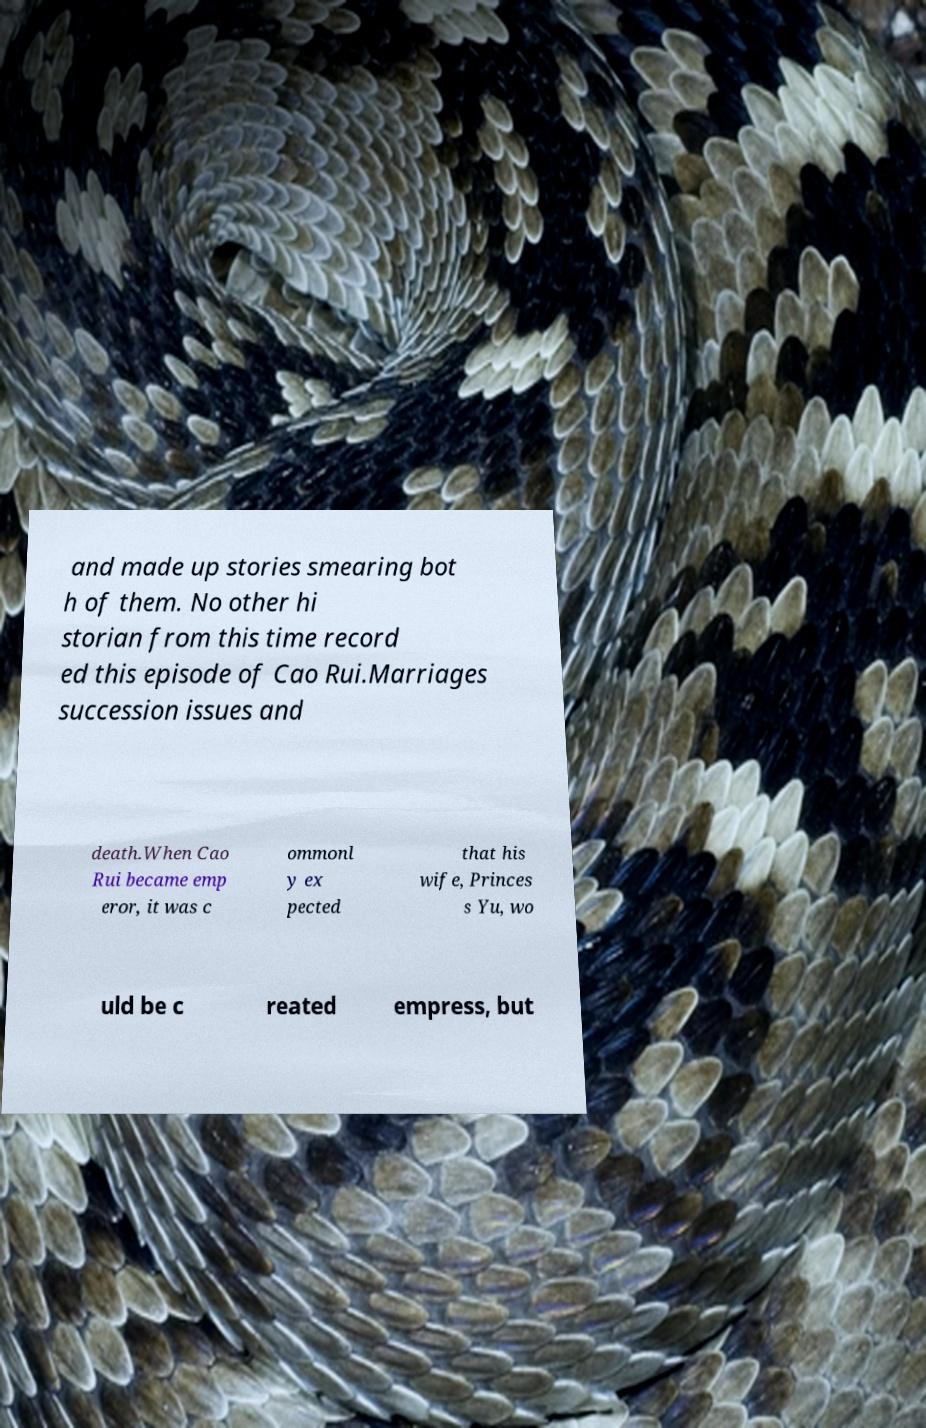Can you accurately transcribe the text from the provided image for me? and made up stories smearing bot h of them. No other hi storian from this time record ed this episode of Cao Rui.Marriages succession issues and death.When Cao Rui became emp eror, it was c ommonl y ex pected that his wife, Princes s Yu, wo uld be c reated empress, but 